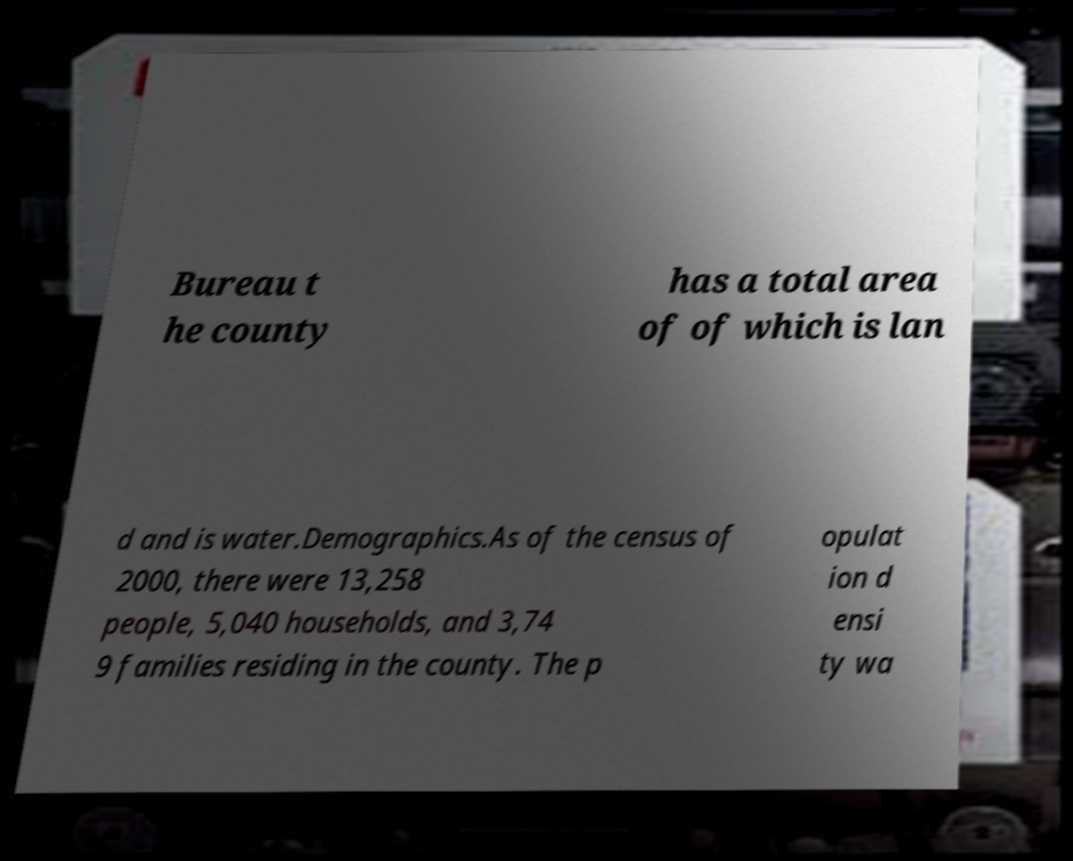Please identify and transcribe the text found in this image. Bureau t he county has a total area of of which is lan d and is water.Demographics.As of the census of 2000, there were 13,258 people, 5,040 households, and 3,74 9 families residing in the county. The p opulat ion d ensi ty wa 